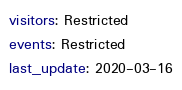Convert code to text. <code><loc_0><loc_0><loc_500><loc_500><_YAML_>visitors: Restricted
events: Restricted
last_update: 2020-03-16
</code> 